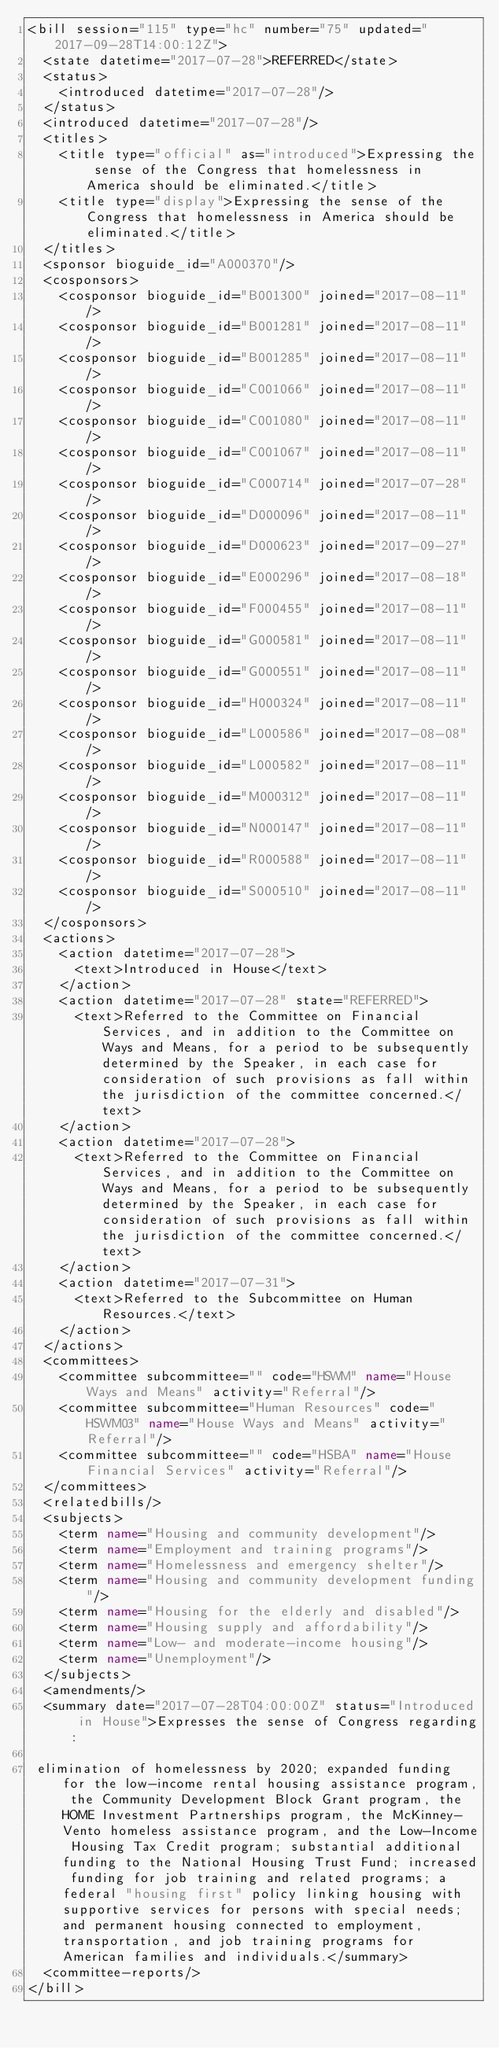Convert code to text. <code><loc_0><loc_0><loc_500><loc_500><_XML_><bill session="115" type="hc" number="75" updated="2017-09-28T14:00:12Z">
  <state datetime="2017-07-28">REFERRED</state>
  <status>
    <introduced datetime="2017-07-28"/>
  </status>
  <introduced datetime="2017-07-28"/>
  <titles>
    <title type="official" as="introduced">Expressing the sense of the Congress that homelessness in America should be eliminated.</title>
    <title type="display">Expressing the sense of the Congress that homelessness in America should be eliminated.</title>
  </titles>
  <sponsor bioguide_id="A000370"/>
  <cosponsors>
    <cosponsor bioguide_id="B001300" joined="2017-08-11"/>
    <cosponsor bioguide_id="B001281" joined="2017-08-11"/>
    <cosponsor bioguide_id="B001285" joined="2017-08-11"/>
    <cosponsor bioguide_id="C001066" joined="2017-08-11"/>
    <cosponsor bioguide_id="C001080" joined="2017-08-11"/>
    <cosponsor bioguide_id="C001067" joined="2017-08-11"/>
    <cosponsor bioguide_id="C000714" joined="2017-07-28"/>
    <cosponsor bioguide_id="D000096" joined="2017-08-11"/>
    <cosponsor bioguide_id="D000623" joined="2017-09-27"/>
    <cosponsor bioguide_id="E000296" joined="2017-08-18"/>
    <cosponsor bioguide_id="F000455" joined="2017-08-11"/>
    <cosponsor bioguide_id="G000581" joined="2017-08-11"/>
    <cosponsor bioguide_id="G000551" joined="2017-08-11"/>
    <cosponsor bioguide_id="H000324" joined="2017-08-11"/>
    <cosponsor bioguide_id="L000586" joined="2017-08-08"/>
    <cosponsor bioguide_id="L000582" joined="2017-08-11"/>
    <cosponsor bioguide_id="M000312" joined="2017-08-11"/>
    <cosponsor bioguide_id="N000147" joined="2017-08-11"/>
    <cosponsor bioguide_id="R000588" joined="2017-08-11"/>
    <cosponsor bioguide_id="S000510" joined="2017-08-11"/>
  </cosponsors>
  <actions>
    <action datetime="2017-07-28">
      <text>Introduced in House</text>
    </action>
    <action datetime="2017-07-28" state="REFERRED">
      <text>Referred to the Committee on Financial Services, and in addition to the Committee on Ways and Means, for a period to be subsequently determined by the Speaker, in each case for consideration of such provisions as fall within the jurisdiction of the committee concerned.</text>
    </action>
    <action datetime="2017-07-28">
      <text>Referred to the Committee on Financial Services, and in addition to the Committee on Ways and Means, for a period to be subsequently determined by the Speaker, in each case for consideration of such provisions as fall within the jurisdiction of the committee concerned.</text>
    </action>
    <action datetime="2017-07-31">
      <text>Referred to the Subcommittee on Human Resources.</text>
    </action>
  </actions>
  <committees>
    <committee subcommittee="" code="HSWM" name="House Ways and Means" activity="Referral"/>
    <committee subcommittee="Human Resources" code="HSWM03" name="House Ways and Means" activity="Referral"/>
    <committee subcommittee="" code="HSBA" name="House Financial Services" activity="Referral"/>
  </committees>
  <relatedbills/>
  <subjects>
    <term name="Housing and community development"/>
    <term name="Employment and training programs"/>
    <term name="Homelessness and emergency shelter"/>
    <term name="Housing and community development funding"/>
    <term name="Housing for the elderly and disabled"/>
    <term name="Housing supply and affordability"/>
    <term name="Low- and moderate-income housing"/>
    <term name="Unemployment"/>
  </subjects>
  <amendments/>
  <summary date="2017-07-28T04:00:00Z" status="Introduced in House">Expresses the sense of Congress regarding:

 elimination of homelessness by 2020; expanded funding for the low-income rental housing assistance program, the Community Development Block Grant program, the HOME Investment Partnerships program, the McKinney-Vento homeless assistance program, and the Low-Income Housing Tax Credit program; substantial additional funding to the National Housing Trust Fund; increased funding for job training and related programs; a federal "housing first" policy linking housing with supportive services for persons with special needs; and permanent housing connected to employment, transportation, and job training programs for American families and individuals.</summary>
  <committee-reports/>
</bill>
</code> 